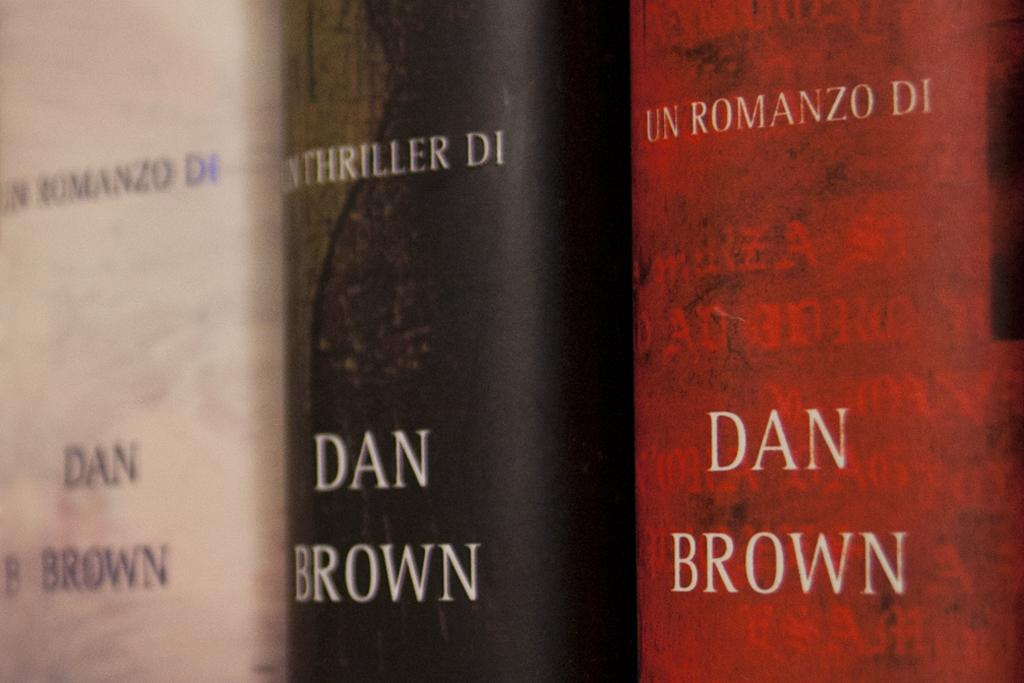<image>
Describe the image concisely. several books, one that is called Dan Brown 